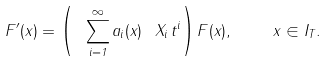<formula> <loc_0><loc_0><loc_500><loc_500>F ^ { \prime } ( x ) = \left ( \ \, \sum _ { i = 1 } ^ { \infty } a _ { i } ( x ) \ \, X _ { i } \, t ^ { i } \right ) F ( x ) , \quad \ x \in I _ { T } .</formula> 